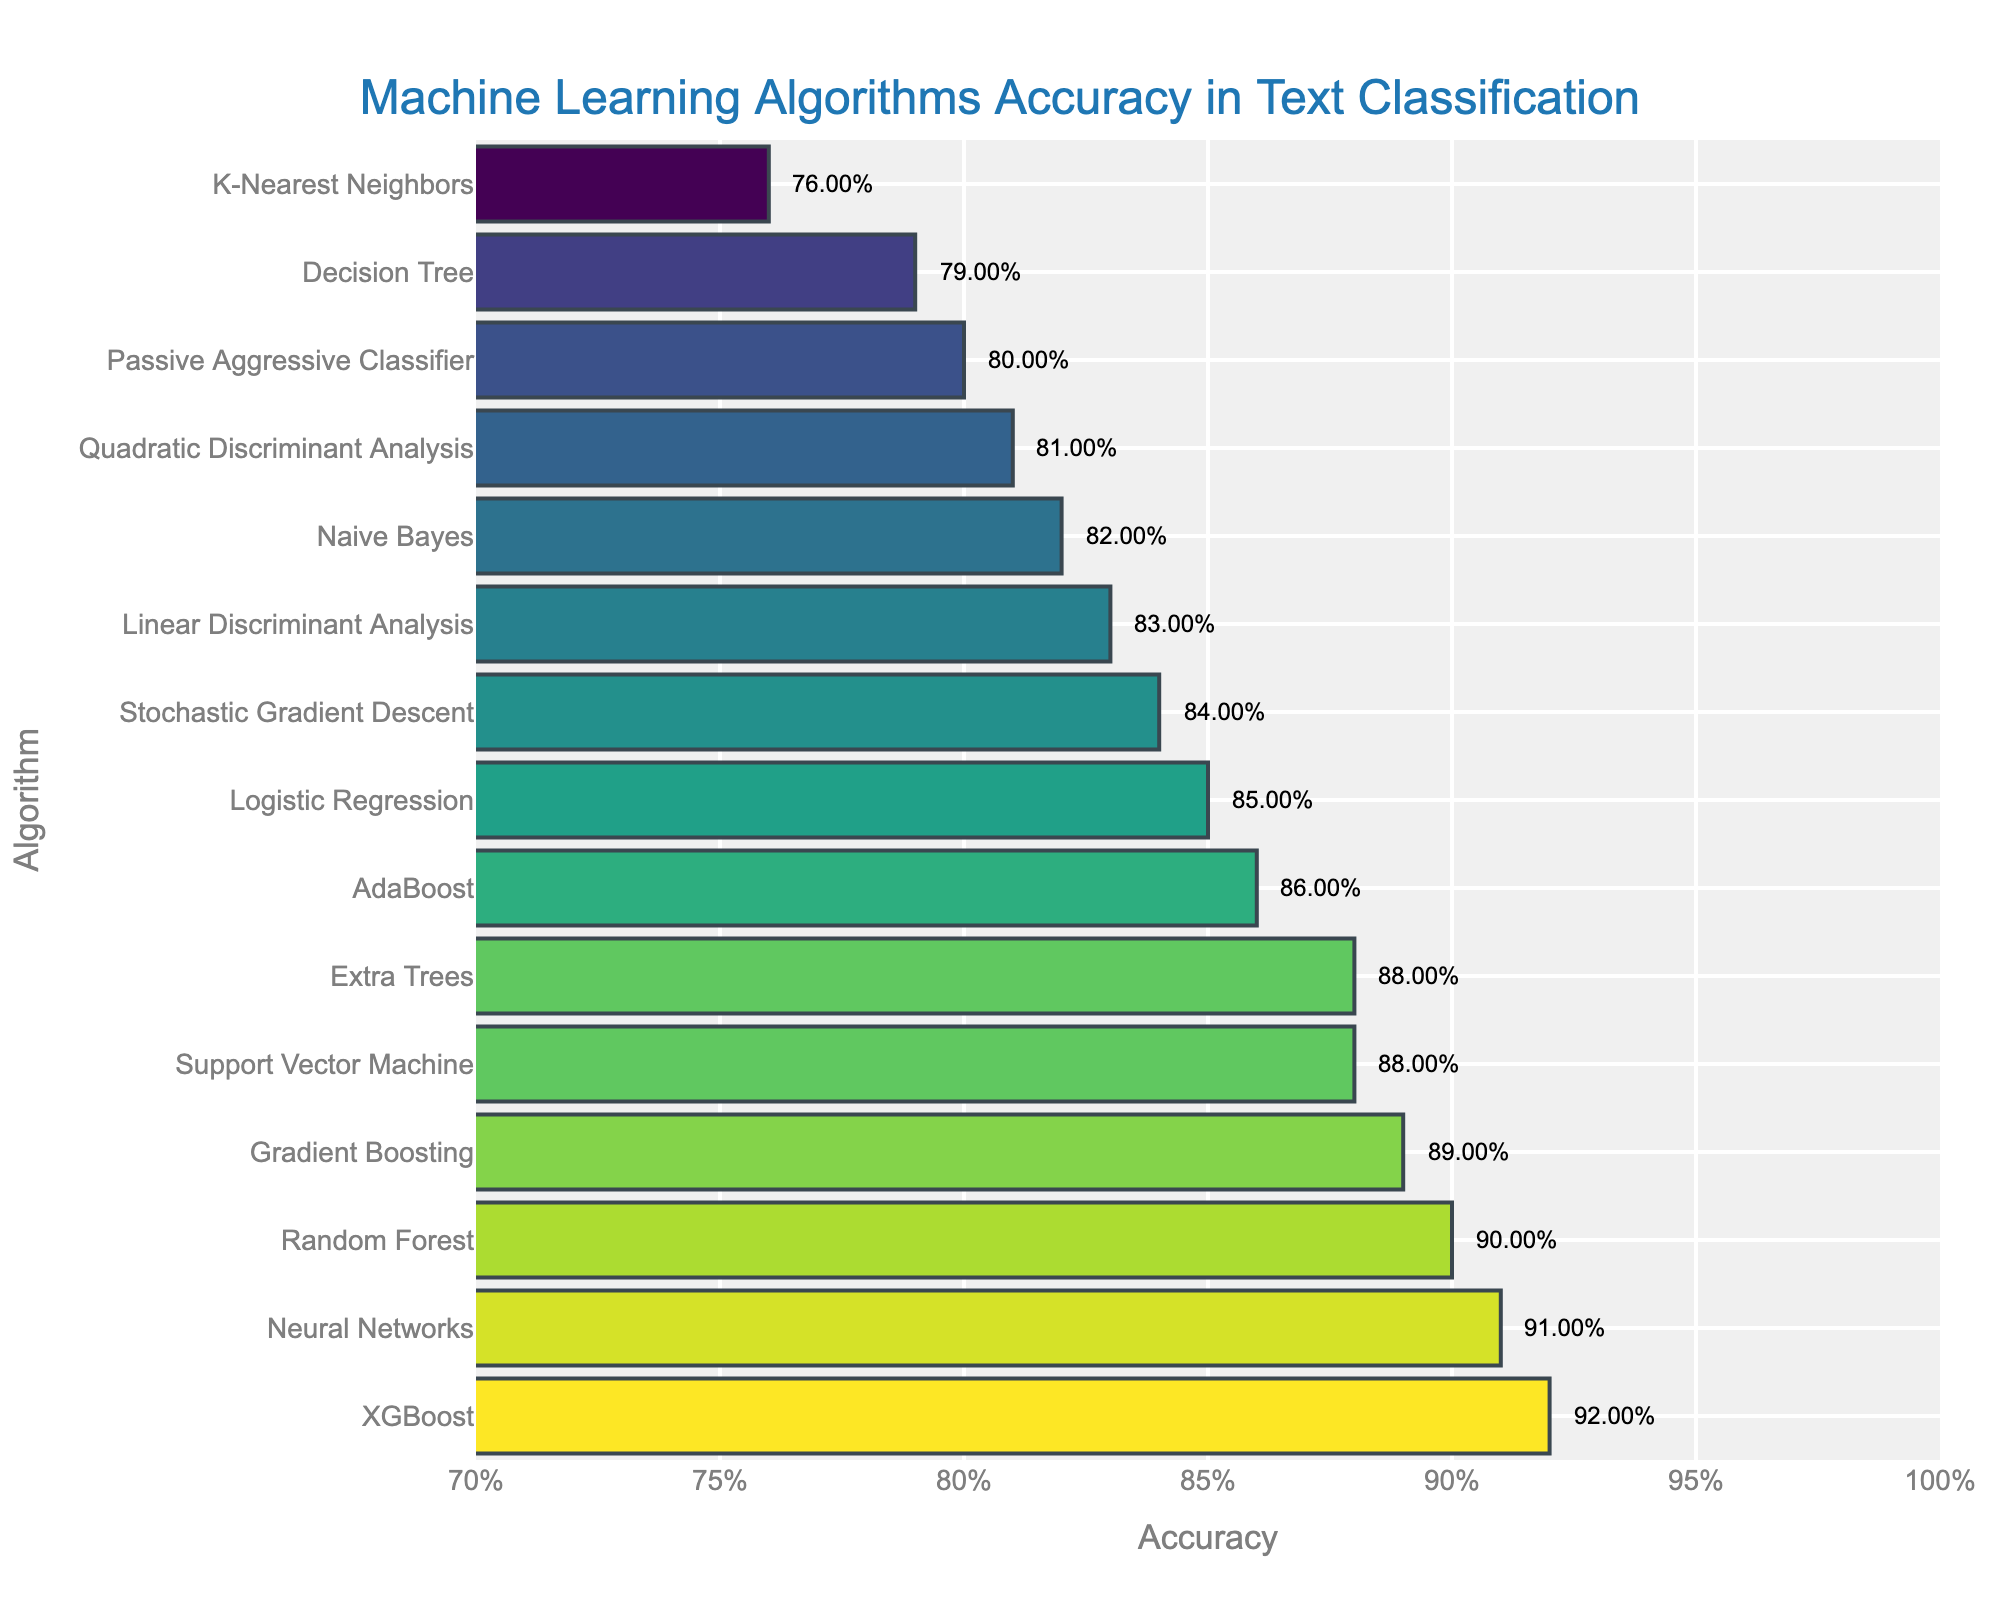Which algorithm has the highest accuracy? The bar with the highest accuracy is represented by the longest bar on the chart, which is labeled "XGBoost".
Answer: XGBoost What is the difference in accuracy between the lowest and highest performing algorithms? The accuracy of the lowest performing algorithm, "K-Nearest Neighbors", is 0.76, and the highest performing algorithm, "XGBoost", has an accuracy of 0.92. The difference is calculated as 0.92 - 0.76 = 0.16.
Answer: 0.16 How many algorithms have an accuracy of 0.88? By looking at the bars labeled "Support Vector Machine" and "Extra Trees", both show an accuracy of 0.88.
Answer: 2 What is the average accuracy of the top 3 algorithms? The accuracies of the top 3 algorithms are "XGBoost" (0.92), "Neural Networks" (0.91), and "Random Forest" (0.90). The average accuracy is calculated as (0.92 + 0.91 + 0.90) / 3 ≈ 0.91.
Answer: 0.91 Which algorithm is less accurate: Naive Bayes or AdaBoost? By comparing the bar lengths, "Naive Bayes" has an accuracy of 0.82, while "AdaBoost" has an accuracy of 0.86, making Naive Bayes less accurate.
Answer: Naive Bayes What is the combined accuracy of Decision Tree, K-Nearest Neighbors, and Passive Aggressive Classifier? The accuracies are "Decision Tree" (0.79), "K-Nearest Neighbors" (0.76), and "Passive Aggressive Classifier" (0.80). The combined accuracy is 0.79 + 0.76 + 0.80 = 2.35.
Answer: 2.35 Are there more algorithms with an accuracy above 0.85 or below 0.85? Algorithms above 0.85: Support Vector Machine, Random Forest, Logistic Regression, Gradient Boosting, Neural Networks, XGBoost, AdaBoost, Extra Trees (8 algorithms). Algorithms below 0.85: Naive Bayes, Decision Tree, K-Nearest Neighbors, Linear Discriminant Analysis, Quadratic Discriminant Analysis, Stochastic Gradient Descent, Passive Aggressive Classifier (7 algorithms). Therefore, there are more algorithms with an accuracy above 0.85.
Answer: Above What is the median accuracy of all shown algorithms? Listing the accuracies in ascending order: 0.76, 0.79, 0.80, 0.81, 0.82, 0.83, 0.84, 0.85, 0.86, 0.88, 0.88, 0.89, 0.90, 0.91, 0.92. The median accuracy is the middle value, which is 0.85.
Answer: 0.85 Which algorithm labeled in the chart has a light green color bar? The colors are mapped to the accuracies, and the bar that is light green corresponds to an accuracy around mid-high values. Looking at the chart, "Gradient Boosting" with 0.89 accuracy likely represents this color.
Answer: Gradient Boosting Is the accuracy of Random Forest closer to Naive Bayes or Support Vector Machine? The accuracy of Random Forest is 0.90, Naive Bayes is 0.82, and Support Vector Machine is 0.88. The differences are calculated:
Answer: 0.88 (Support Vector Machine is closer to Random Forest) 